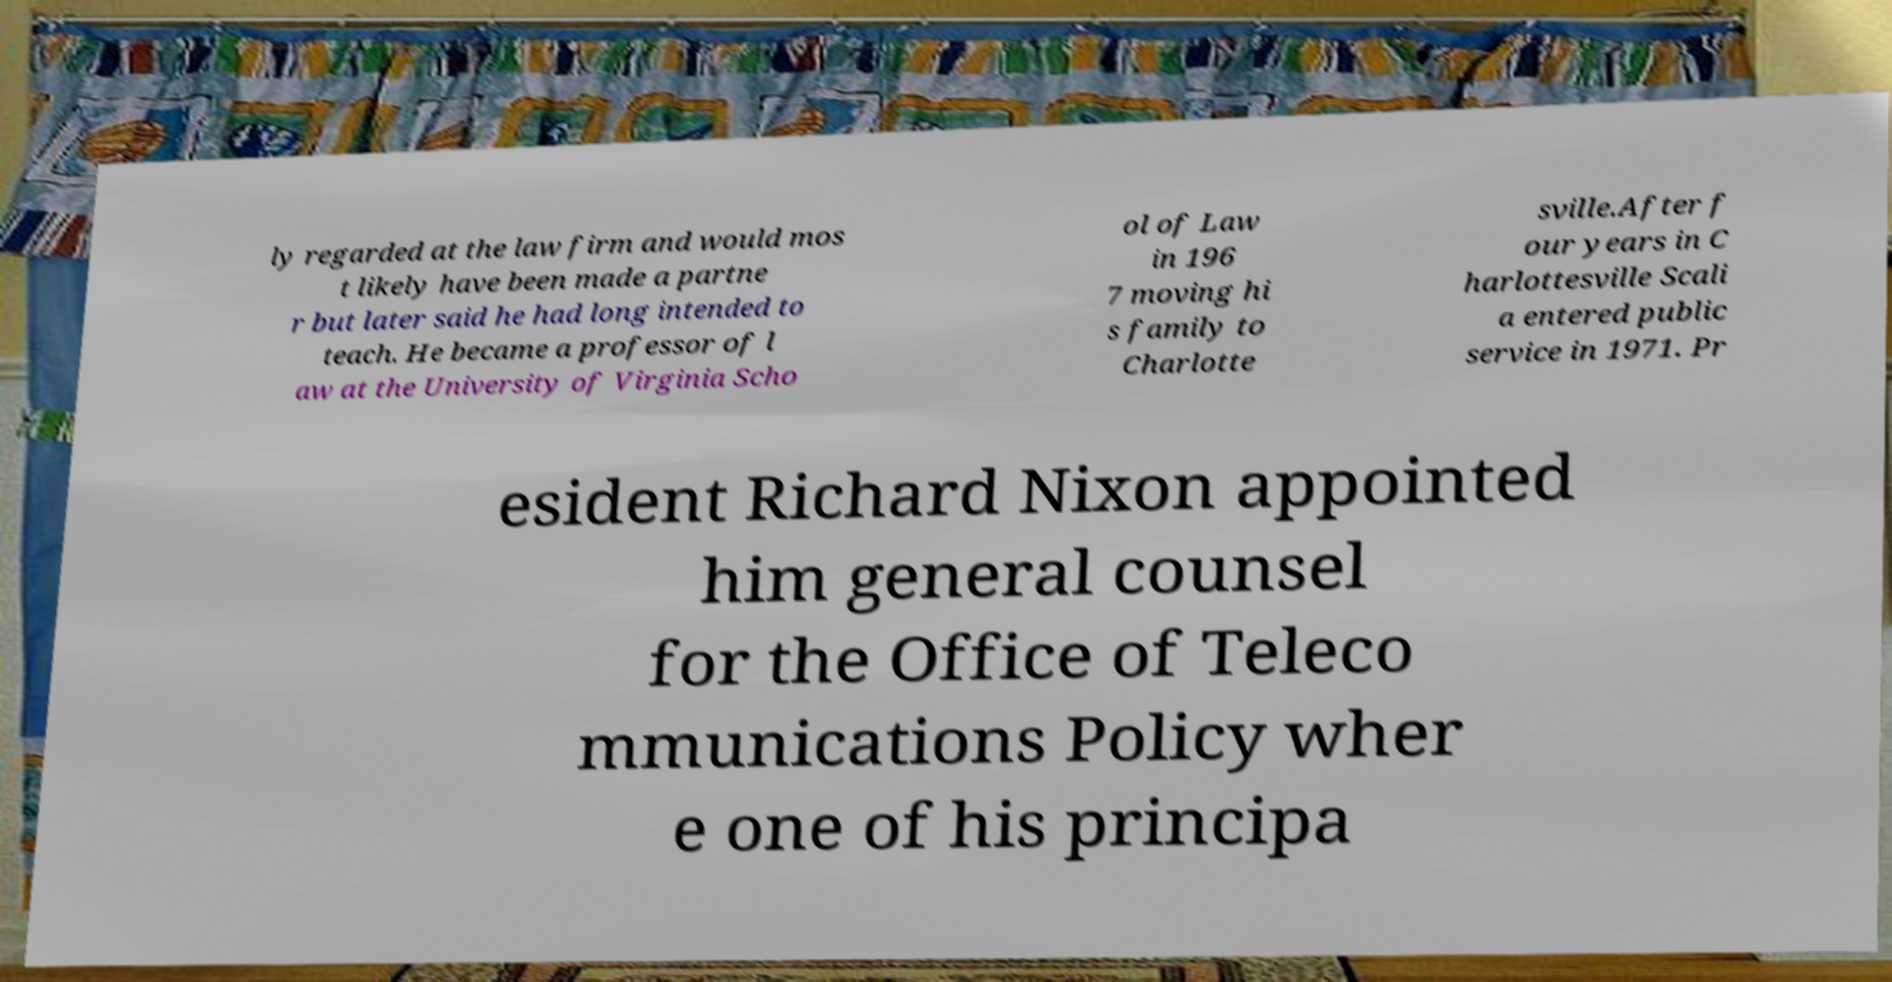I need the written content from this picture converted into text. Can you do that? ly regarded at the law firm and would mos t likely have been made a partne r but later said he had long intended to teach. He became a professor of l aw at the University of Virginia Scho ol of Law in 196 7 moving hi s family to Charlotte sville.After f our years in C harlottesville Scali a entered public service in 1971. Pr esident Richard Nixon appointed him general counsel for the Office of Teleco mmunications Policy wher e one of his principa 